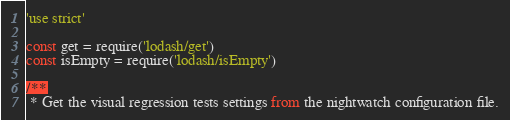Convert code to text. <code><loc_0><loc_0><loc_500><loc_500><_JavaScript_>'use strict'

const get = require('lodash/get')
const isEmpty = require('lodash/isEmpty')

/**
 * Get the visual regression tests settings from the nightwatch configuration file.</code> 